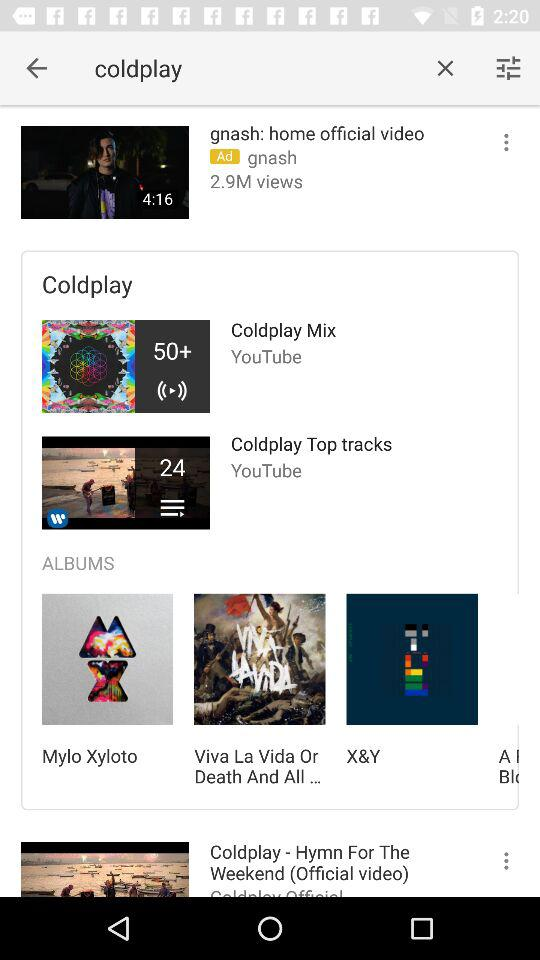How many tracks are there under the "Coldplay Top Tracks" playlist? There are 24 tracks. 